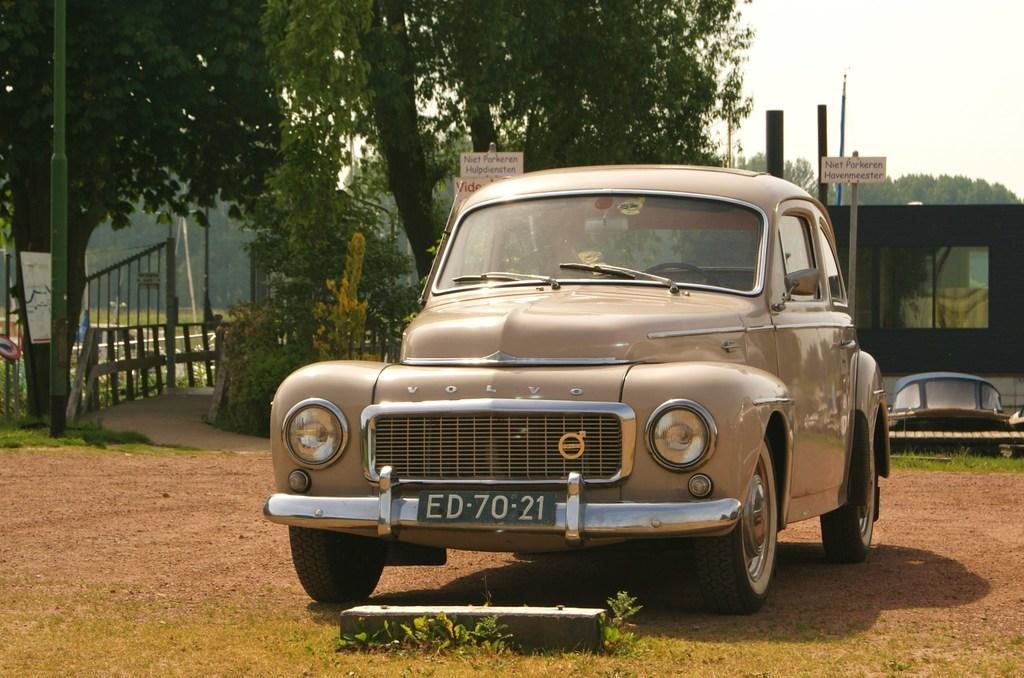Can you describe this image briefly? In this picture I can see a car in front and I see a number plate on it and it is on the ground. In the background I can see few poles and boards on which there is something written and I can also see the plants, trees and on the left side of this image I can see the fencing. On the top right of this picture I can see the sky. 